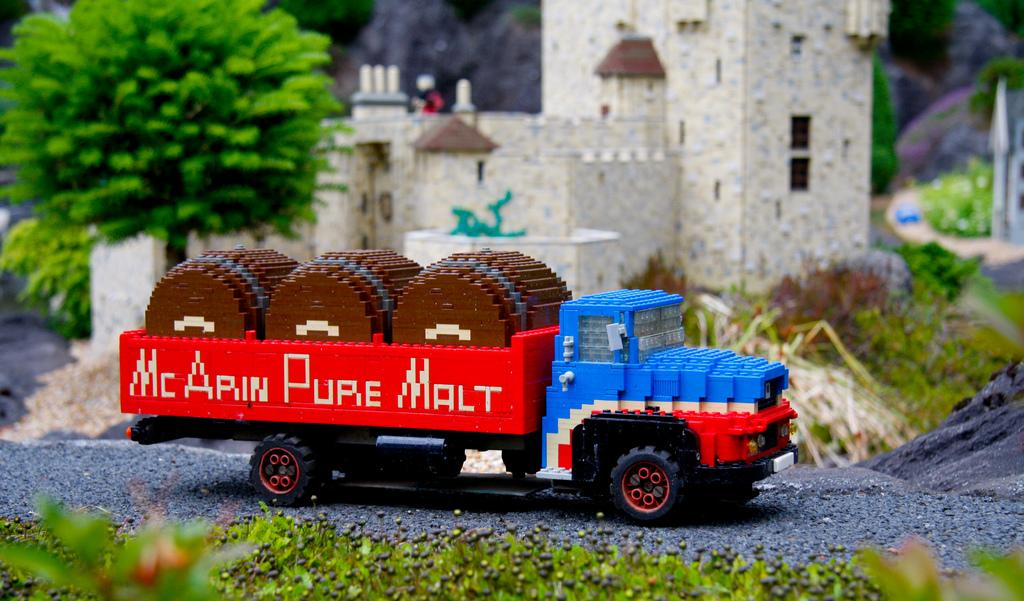What is the main subject of the image? There is a vehicle in the image. What type of objects are made of Lego in the image? There are objects made of Lego in the image. What can be seen in the background of the image? There are buildings, trees, and other unspecified objects in the background of the image. What word is written on the side of the vehicle in the image? There is no word written on the side of the vehicle in the image. Can you provide an example of one of the unspecified objects in the background of the image? Since the unspecified objects are not described in the facts, we cannot provide an example of one of them. 